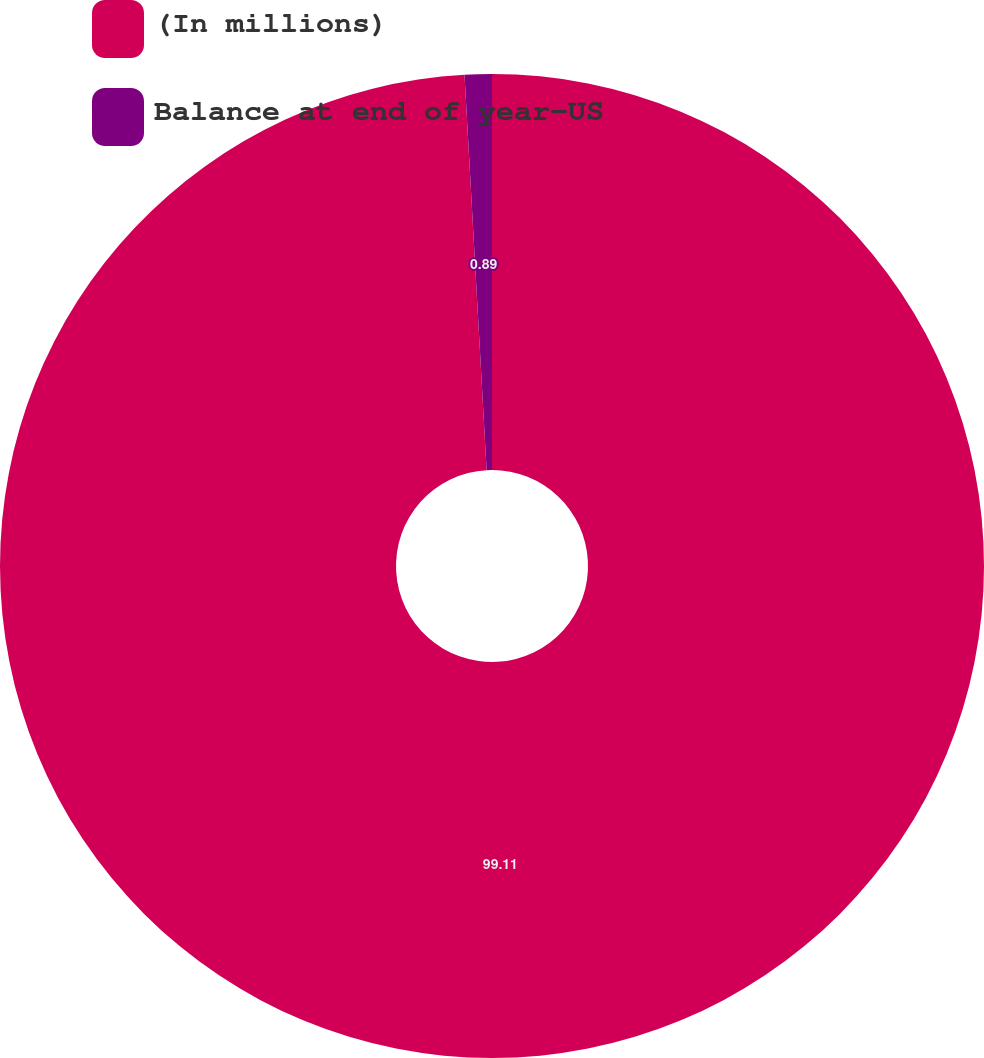<chart> <loc_0><loc_0><loc_500><loc_500><pie_chart><fcel>(In millions)<fcel>Balance at end of year-US<nl><fcel>99.11%<fcel>0.89%<nl></chart> 